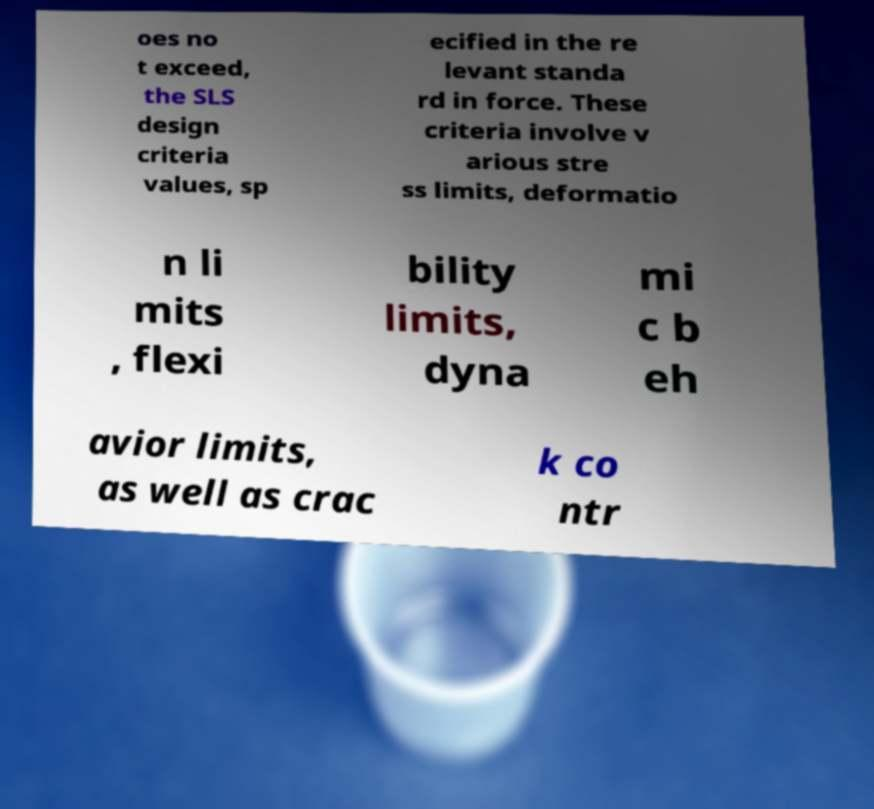Can you accurately transcribe the text from the provided image for me? oes no t exceed, the SLS design criteria values, sp ecified in the re levant standa rd in force. These criteria involve v arious stre ss limits, deformatio n li mits , flexi bility limits, dyna mi c b eh avior limits, as well as crac k co ntr 